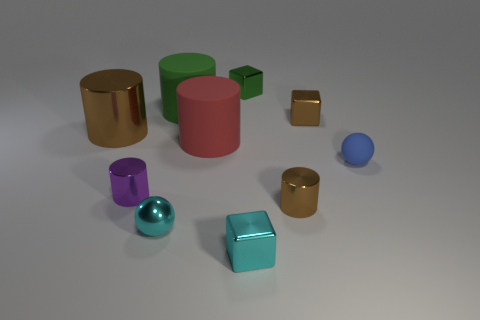The purple metal cylinder is what size?
Your answer should be very brief. Small. How many blue balls have the same size as the blue matte object?
Offer a terse response. 0. Do the tiny metal ball and the tiny rubber thing have the same color?
Provide a short and direct response. No. Is the material of the green object in front of the green cube the same as the brown object that is to the left of the cyan ball?
Provide a succinct answer. No. Are there more gray matte spheres than cyan metallic cubes?
Provide a succinct answer. No. Is there anything else that is the same color as the big metal object?
Offer a terse response. Yes. Do the large red cylinder and the tiny green object have the same material?
Keep it short and to the point. No. Is the number of gray cubes less than the number of small cyan metallic things?
Your answer should be very brief. Yes. Do the large green object and the small matte thing have the same shape?
Offer a very short reply. No. The matte ball is what color?
Give a very brief answer. Blue. 